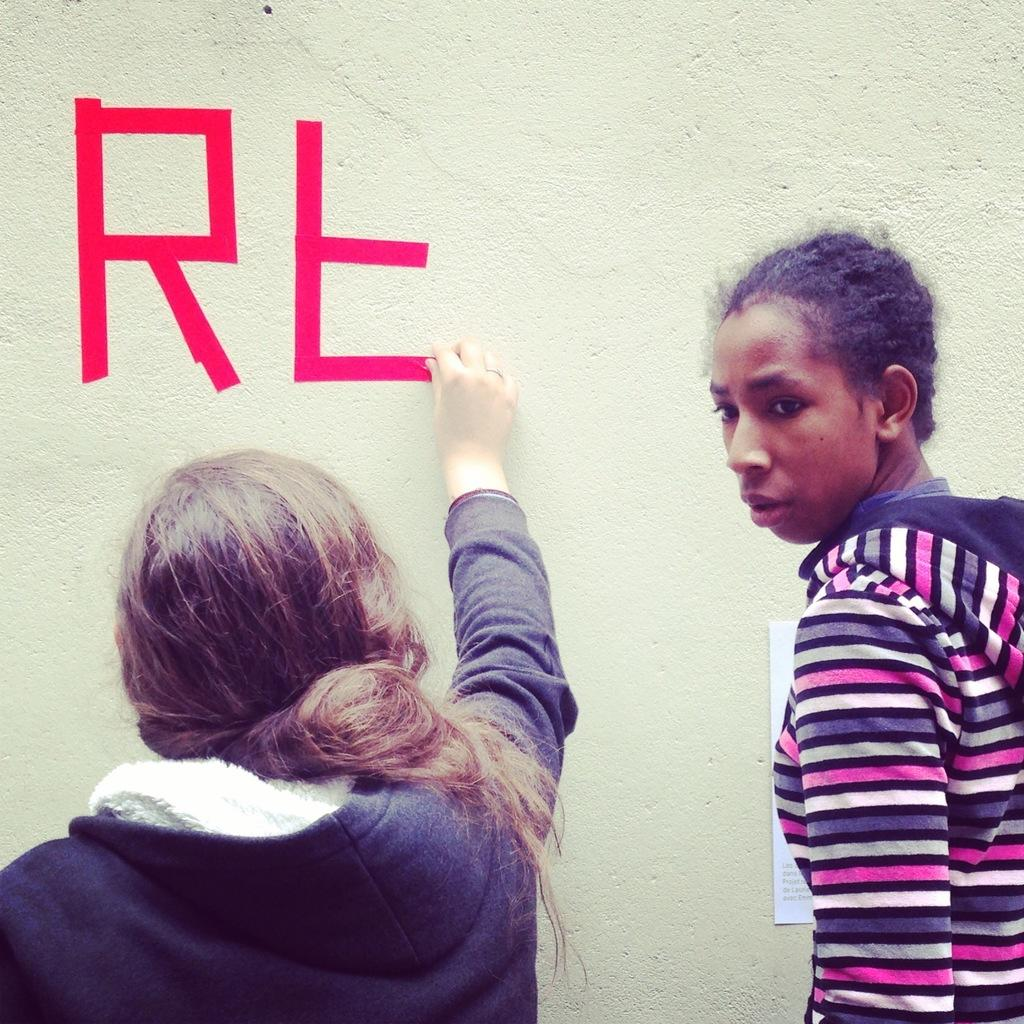How many girls are present in the image? There are two girls in the image. What is the girl on the left side doing? The girl on the left side is sticking the plaster on the wall. What type of sail can be seen on the peace sign in the image? There is no sail or peace sign present in the image; it features two girls, one of whom is sticking plaster on the wall. 